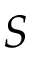<formula> <loc_0><loc_0><loc_500><loc_500>S</formula> 